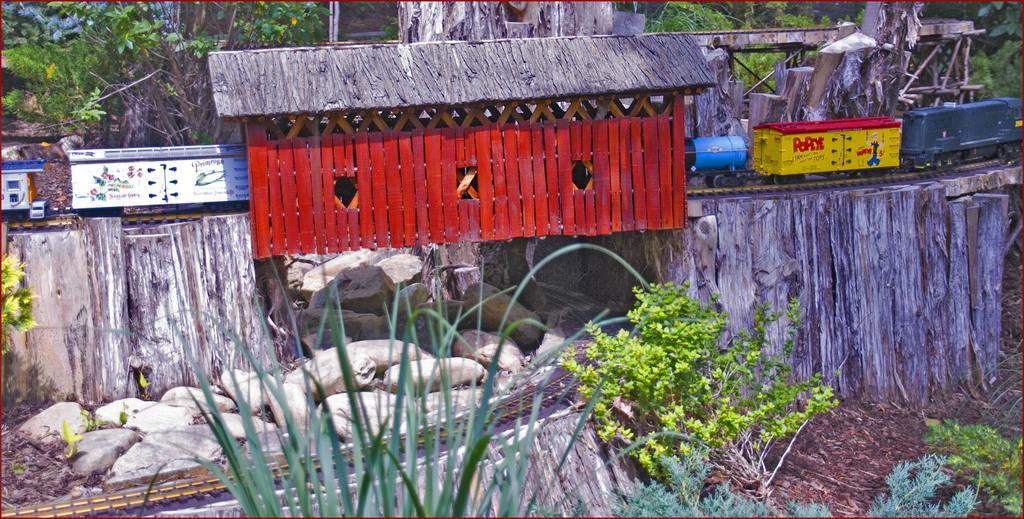Could you give a brief overview of what you see in this image? In the picture we can see a setting of a plant and near to it, we can see some wooden railing and a small hut on it which is red in color and we can see a train on the track and behind it we can see plants. 